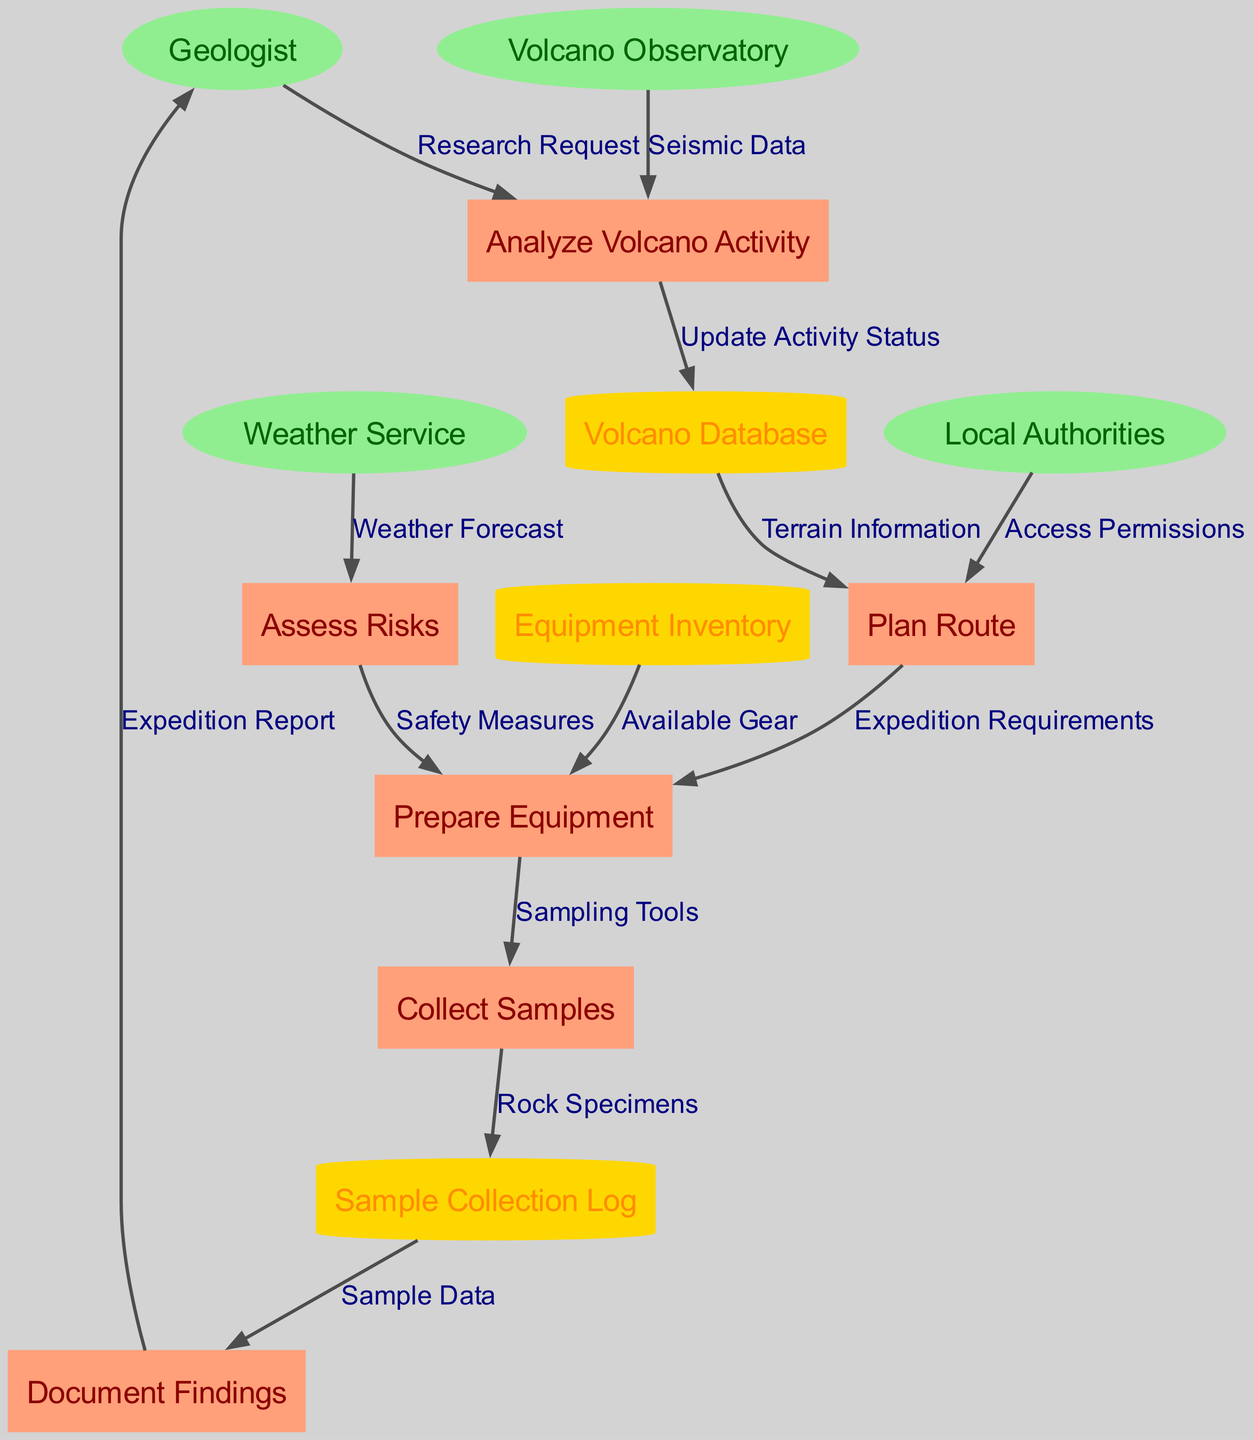What are the external entities in the diagram? The diagram lists four external entities: Geologist, Weather Service, Volcano Observatory, and Local Authorities.
Answer: Geologist, Weather Service, Volcano Observatory, Local Authorities How many processes are represented in the diagram? By counting all the listed processes, we can find that there are six processes: Analyze Volcano Activity, Plan Route, Prepare Equipment, Assess Risks, Collect Samples, and Document Findings.
Answer: Six Which process receives a Weather Forecast? The data flow indicates that the Assess Risks process receives information specifically labeled as Weather Forecast from the Weather Service.
Answer: Assess Risks What data store is updated by the Analyze Volcano Activity process? The Analyze Volcano Activity process updates the Volcano Database, as indicated in the data flow labeled "Update Activity Status."
Answer: Volcano Database How many relationships are there from Local Authorities? There is one direct relationship from Local Authorities to Plan Route, which is labeled Access Permissions. Thus, the count of relationships emanating from Local Authorities is one.
Answer: One What is the output of the Collect Samples process? The output of the Collect Samples process is rock specimens, which are logged into the Sample Collection Log. This is shown in the data flow labeled "Rock Specimens."
Answer: Rock Specimens What are the required inputs for the Prepare Equipment process? The Prepare Equipment process requires three inputs: Expedition Requirements from the Plan Route process, Available Gear from Equipment Inventory, and Safety Measures from Assess Risks.
Answer: Expedition Requirements, Available Gear, Safety Measures Which external entity is responsible for sending seismic data? The Volcano Observatory is responsible for sending seismic data to the Analyze Volcano Activity process, as indicated by the relevant data flow.
Answer: Volcano Observatory Which data store contains sample data? The Sample Collection Log contains the sample data that is subsequently used in the Document Findings process. This can be verified through the data flow labeled "Sample Data."
Answer: Sample Collection Log 